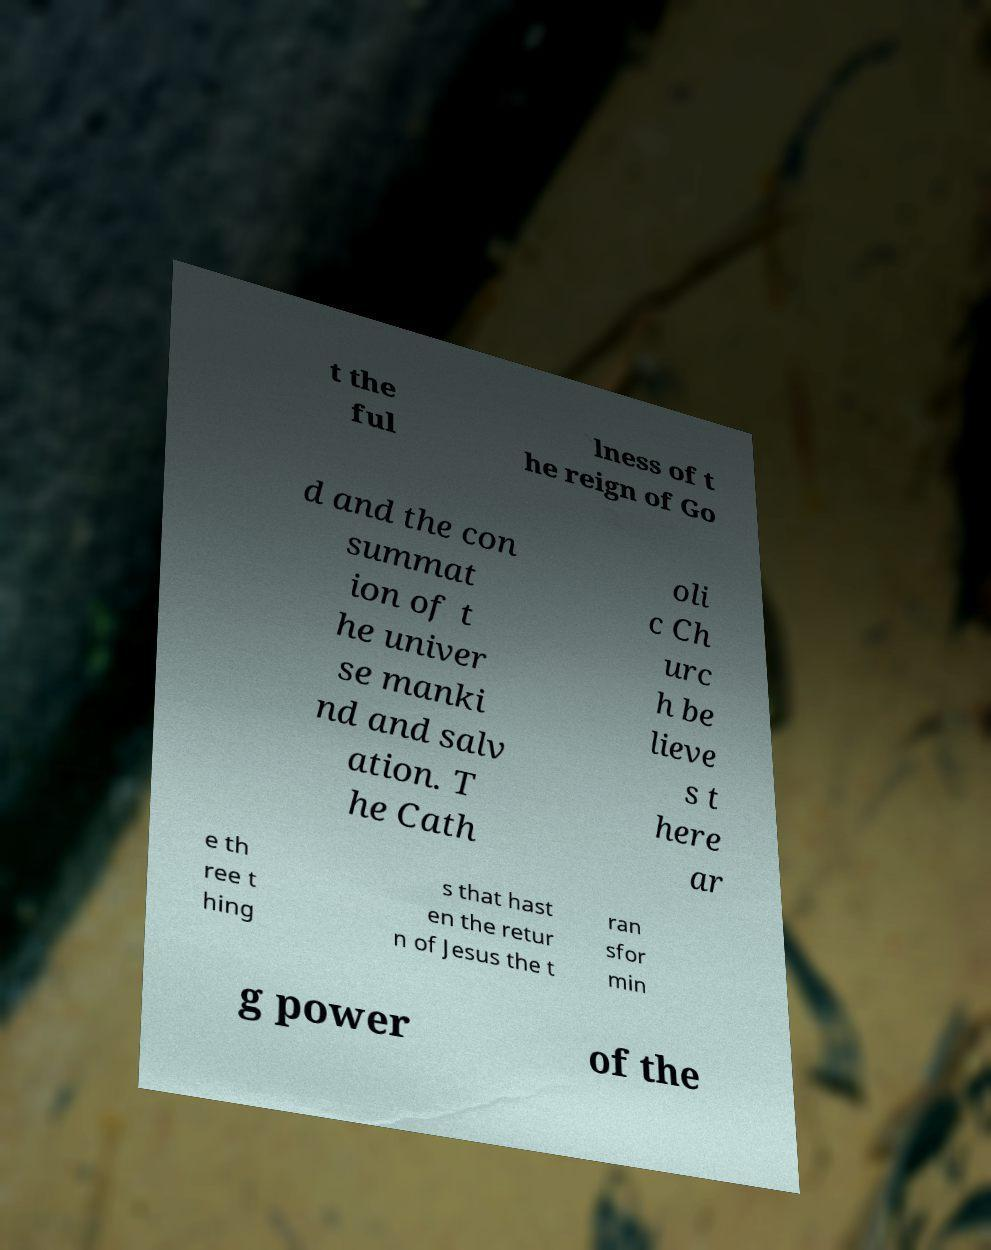Could you assist in decoding the text presented in this image and type it out clearly? t the ful lness of t he reign of Go d and the con summat ion of t he univer se manki nd and salv ation. T he Cath oli c Ch urc h be lieve s t here ar e th ree t hing s that hast en the retur n of Jesus the t ran sfor min g power of the 